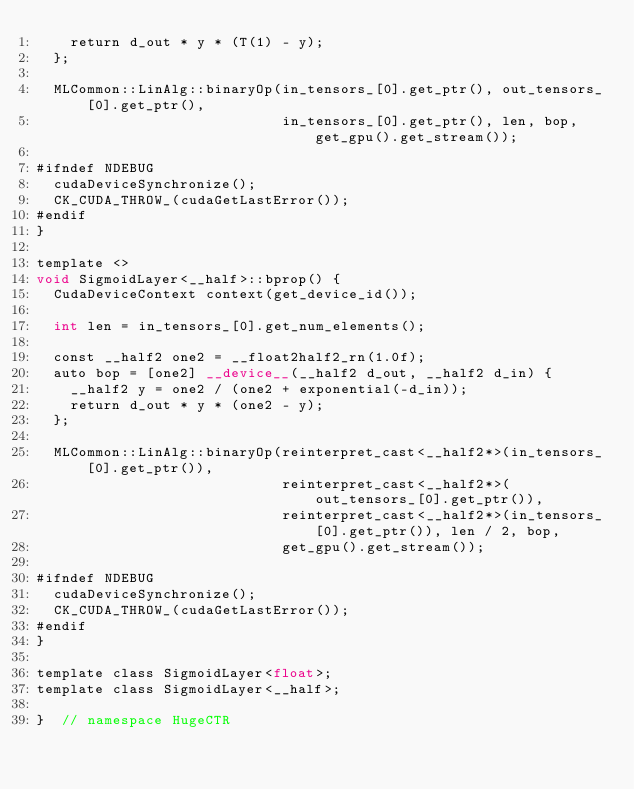Convert code to text. <code><loc_0><loc_0><loc_500><loc_500><_Cuda_>    return d_out * y * (T(1) - y);
  };

  MLCommon::LinAlg::binaryOp(in_tensors_[0].get_ptr(), out_tensors_[0].get_ptr(),
                             in_tensors_[0].get_ptr(), len, bop, get_gpu().get_stream());

#ifndef NDEBUG
  cudaDeviceSynchronize();
  CK_CUDA_THROW_(cudaGetLastError());
#endif
}

template <>
void SigmoidLayer<__half>::bprop() {
  CudaDeviceContext context(get_device_id());

  int len = in_tensors_[0].get_num_elements();

  const __half2 one2 = __float2half2_rn(1.0f);
  auto bop = [one2] __device__(__half2 d_out, __half2 d_in) {
    __half2 y = one2 / (one2 + exponential(-d_in));
    return d_out * y * (one2 - y);
  };

  MLCommon::LinAlg::binaryOp(reinterpret_cast<__half2*>(in_tensors_[0].get_ptr()),
                             reinterpret_cast<__half2*>(out_tensors_[0].get_ptr()),
                             reinterpret_cast<__half2*>(in_tensors_[0].get_ptr()), len / 2, bop,
                             get_gpu().get_stream());

#ifndef NDEBUG
  cudaDeviceSynchronize();
  CK_CUDA_THROW_(cudaGetLastError());
#endif
}

template class SigmoidLayer<float>;
template class SigmoidLayer<__half>;

}  // namespace HugeCTR
</code> 